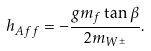<formula> <loc_0><loc_0><loc_500><loc_500>h _ { A f f } = - \frac { g m _ { f } \tan \beta } { 2 m _ { W ^ { \pm } } } .</formula> 